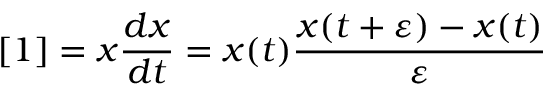Convert formula to latex. <formula><loc_0><loc_0><loc_500><loc_500>[ 1 ] = x { \frac { d x } { d t } } = x ( t ) { \frac { x ( t + \varepsilon ) - x ( t ) } { \varepsilon } }</formula> 